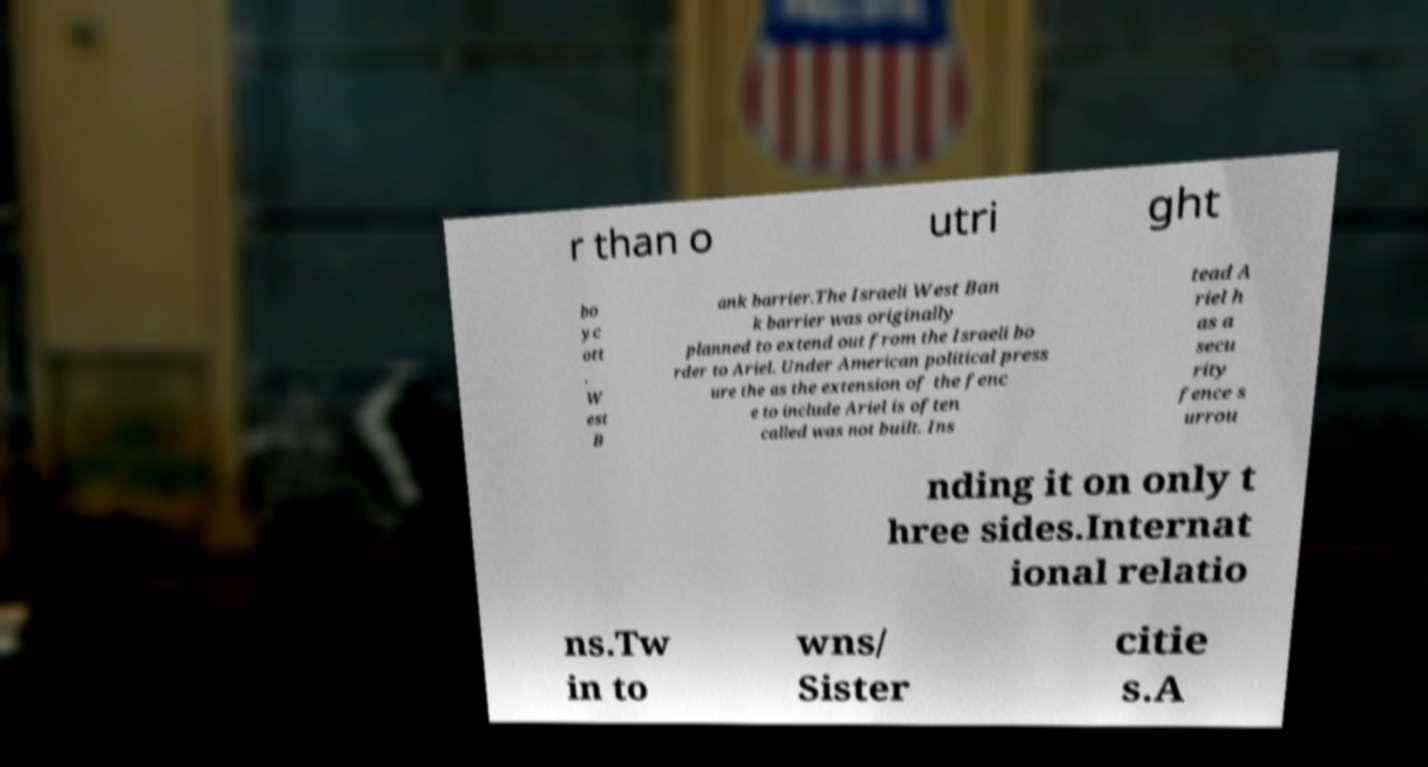Please read and relay the text visible in this image. What does it say? r than o utri ght bo yc ott . W est B ank barrier.The Israeli West Ban k barrier was originally planned to extend out from the Israeli bo rder to Ariel. Under American political press ure the as the extension of the fenc e to include Ariel is often called was not built. Ins tead A riel h as a secu rity fence s urrou nding it on only t hree sides.Internat ional relatio ns.Tw in to wns/ Sister citie s.A 